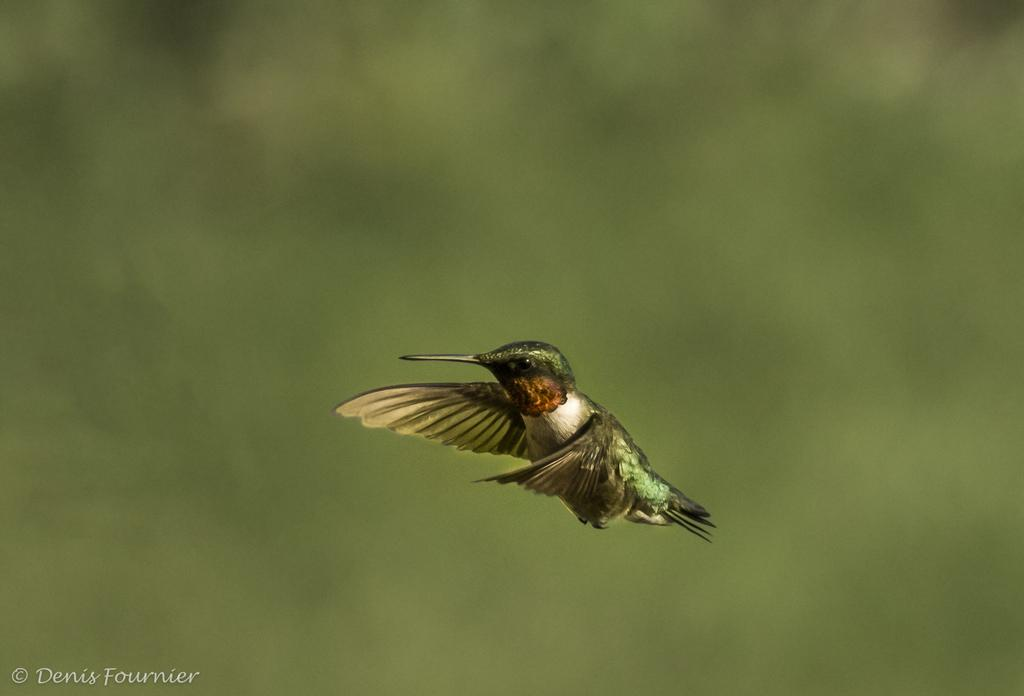What type of animal is in the image? There is a bird in the image. What color is the bird? The bird is green in color. What feature can be observed on the bird's face? The bird has a sharp beak. What is the color of the background in the image? The background of the image is green. How would you describe the focus of the image? The background is blurred. How many bones can be seen in the image? There are no bones present in the image. What type of fact can be learned from the image? The image does not convey any specific fact; it is a photograph of a green bird with a sharp beak against a green background. 